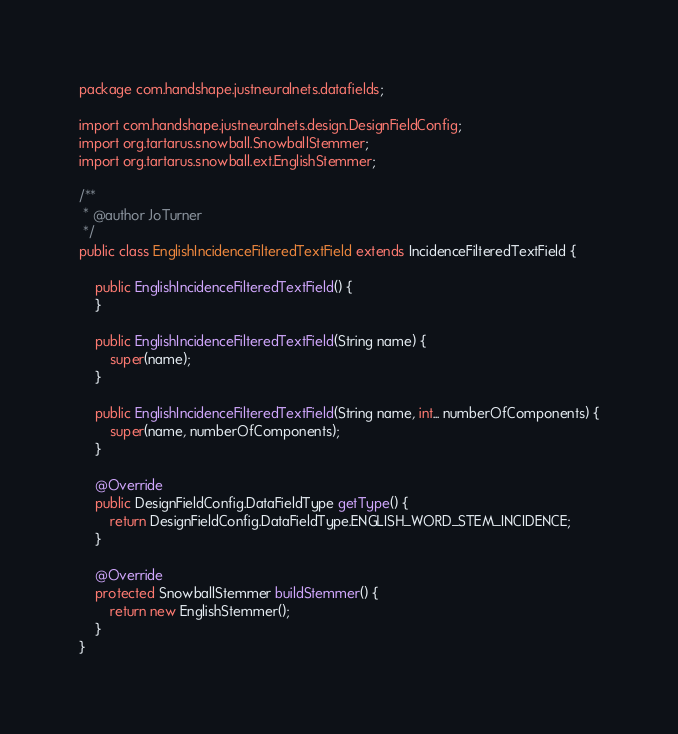Convert code to text. <code><loc_0><loc_0><loc_500><loc_500><_Java_>package com.handshape.justneuralnets.datafields;

import com.handshape.justneuralnets.design.DesignFieldConfig;
import org.tartarus.snowball.SnowballStemmer;
import org.tartarus.snowball.ext.EnglishStemmer;

/**
 * @author JoTurner
 */
public class EnglishIncidenceFilteredTextField extends IncidenceFilteredTextField {

    public EnglishIncidenceFilteredTextField() {
    }

    public EnglishIncidenceFilteredTextField(String name) {
        super(name);
    }

    public EnglishIncidenceFilteredTextField(String name, int... numberOfComponents) {
        super(name, numberOfComponents);
    }

    @Override
    public DesignFieldConfig.DataFieldType getType() {
        return DesignFieldConfig.DataFieldType.ENGLISH_WORD_STEM_INCIDENCE;
    }

    @Override
    protected SnowballStemmer buildStemmer() {
        return new EnglishStemmer();
    }
}
</code> 